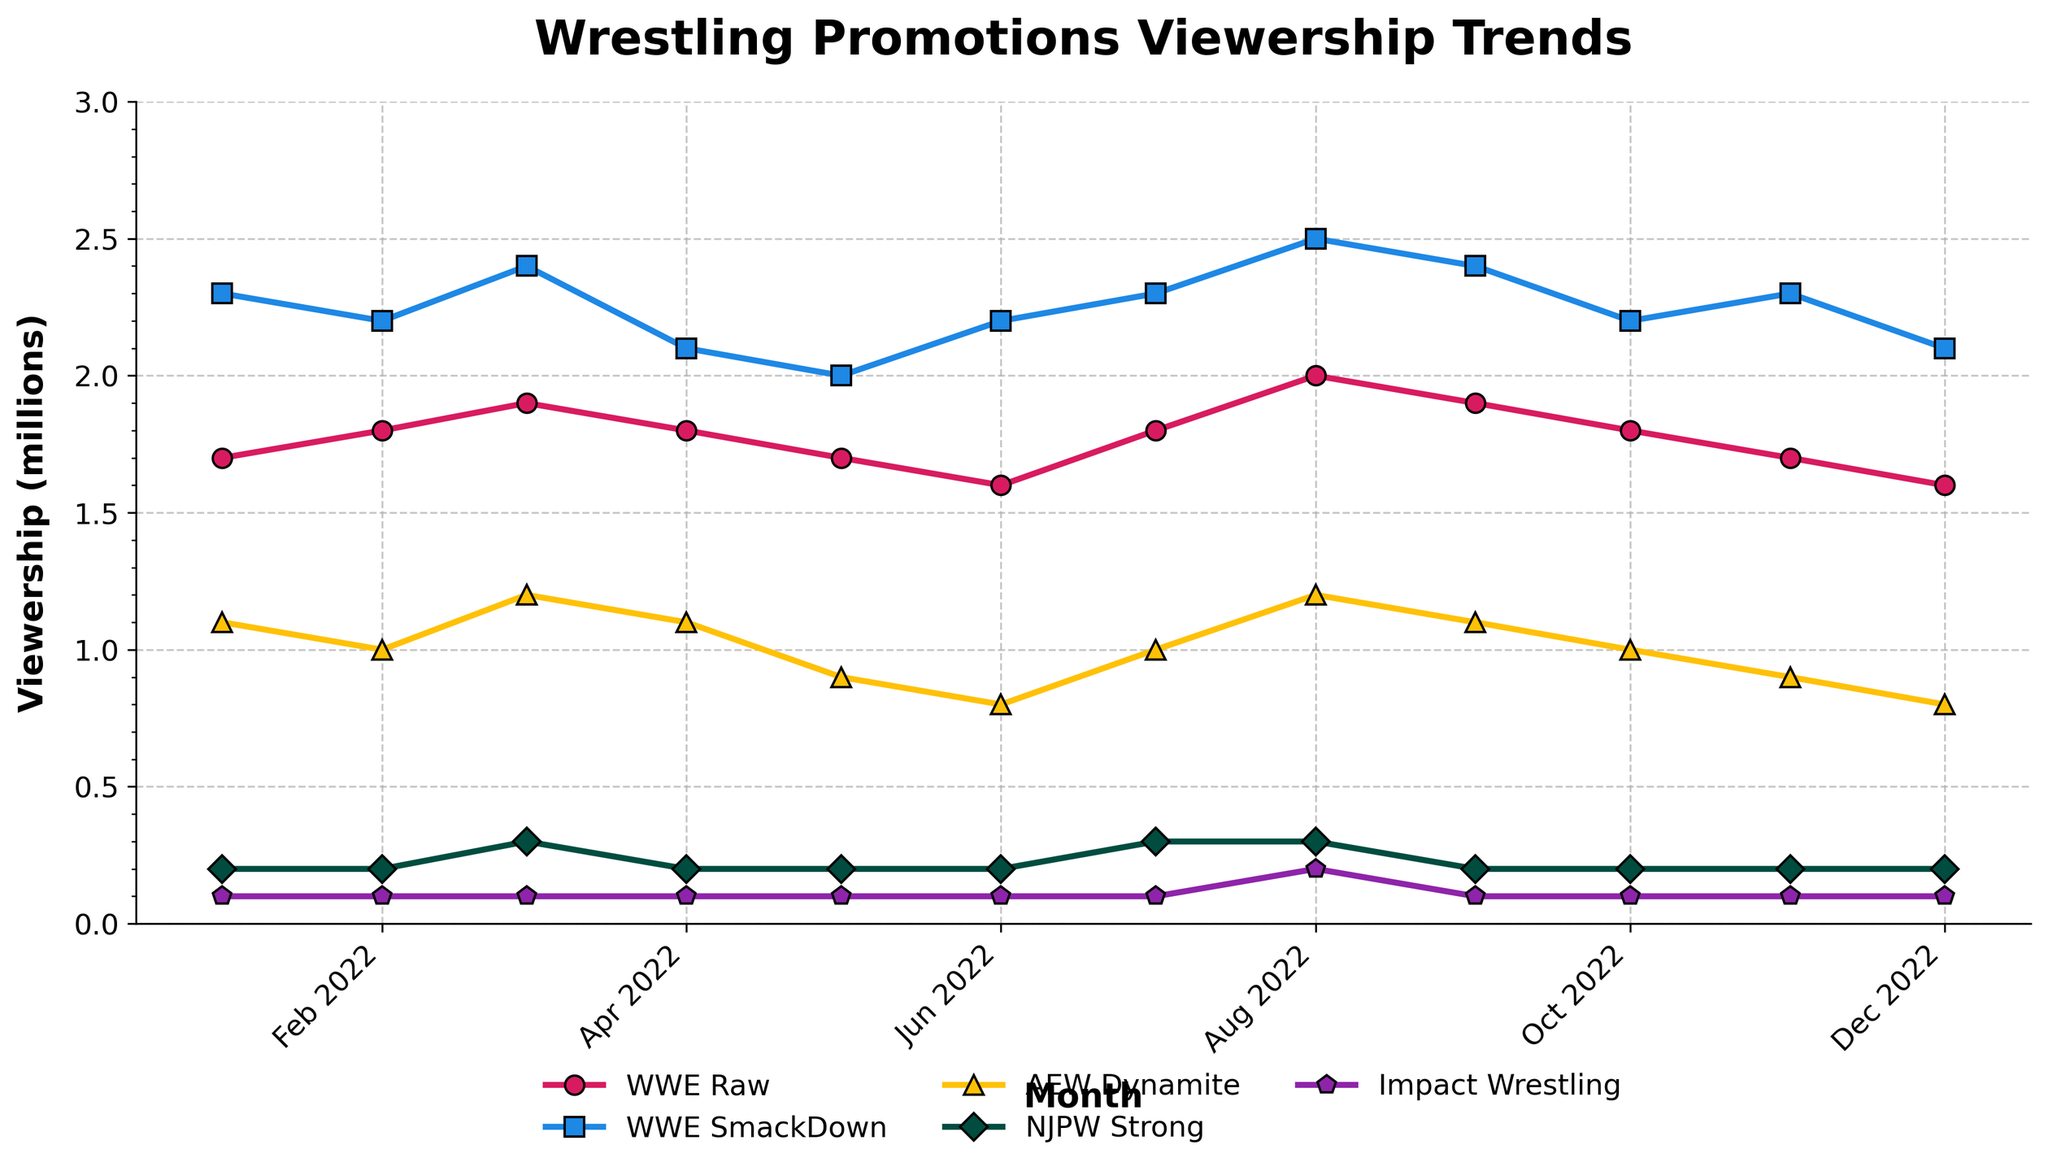Which promotion had the highest viewership in December 2022? To find which promotion had the highest viewership in December 2022, look at the data points corresponding to December for each promotion and compare them. WWE SmackDown had the highest viewership with 2.1 million.
Answer: WWE SmackDown Between WWE Raw and AEW Dynamite, which had a more stable viewership trend throughout the year 2022? To determine which had a more stable trend, observe the fluctuation in the data points for both WWE Raw and AEW Dynamite. WWE Raw fluctuated between 1.6 and 1.9 million, whereas AEW Dynamite fluctuated between 0.8 and 1.2 million. WWE Raw shows a more stable trend as its range of fluctuation is smaller.
Answer: WWE Raw By how much did WWE SmackDown's viewership change from January 2022 to August 2022? Find the difference between WWE SmackDown's viewership in January (2.3 million) and August (2.5 million). The change is 2.5 - 2.3 = 0.2 million.
Answer: 0.2 million Which promotion had the lowest overall viewership throughout the year? By observing the entire trend for all promotions over the year, it is apparent that Impact Wrestling consistently had the lowest viewership numbers, remaining at 0.1 million every month except in August (0.2 million).
Answer: Impact Wrestling What was the average viewership for AEW Dynamite in 2022? Sum the monthly viewership numbers for AEW Dynamite from January to December and then divide by 12. The sum is (1.1 + 1.0 + 1.2 + 1.1 + 0.9 + 0.8 + 1.0 + 1.2 + 1.1 + 1.0 + 0.9 + 0.8) = 12.1. So, the average is 12.1 / 12 = 1.008 million.
Answer: 1.008 million What month did NJPW Strong have its highest viewership? By examining the NJPW Strong data points, the highest viewership was in March and August 2022 with values of 0.3 million.
Answer: March and August Comparing the viewership in June 2022, how did WWE Raw and WWE SmackDown differ? Look at the viewership values for June 2022 for both WWE Raw and WWE SmackDown. WWE Raw had 1.6 million, and WWE SmackDown had 2.2 million. The difference is 2.2 - 1.6 = 0.6 million.
Answer: 0.6 million Which line representing a promotion shows the steepest decline in viewership from one month to another? By visually examining the trends, AEW Dynamite from May to June shows the steepest decline, from 0.9 million to 0.8 million, a decline of 0.1 million.
Answer: AEW Dynamite What was the viewership trend for Impact Wrestling throughout 2022? Observe the Impact Wrestling line throughout the year. It remained flat at 0.1 million from January to November and only increased to 0.2 million in August.
Answer: Mostly flat, slight increase in August How did the viewership for WWE Raw and AEW Dynamite compare in July 2022? Look at the data points for WWE Raw and AEW Dynamite in July 2022. WWE Raw had 1.8 million, while AEW Dynamite had 1.0 million. WWE Raw had higher viewership.
Answer: WWE Raw had higher viewership 